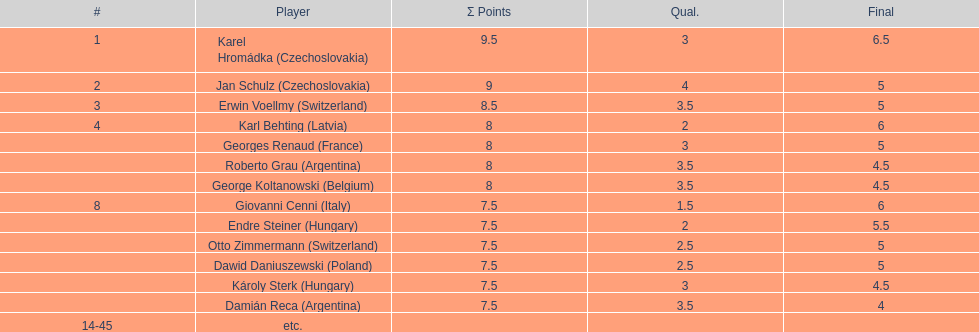How many players had a 8 points? 4. 